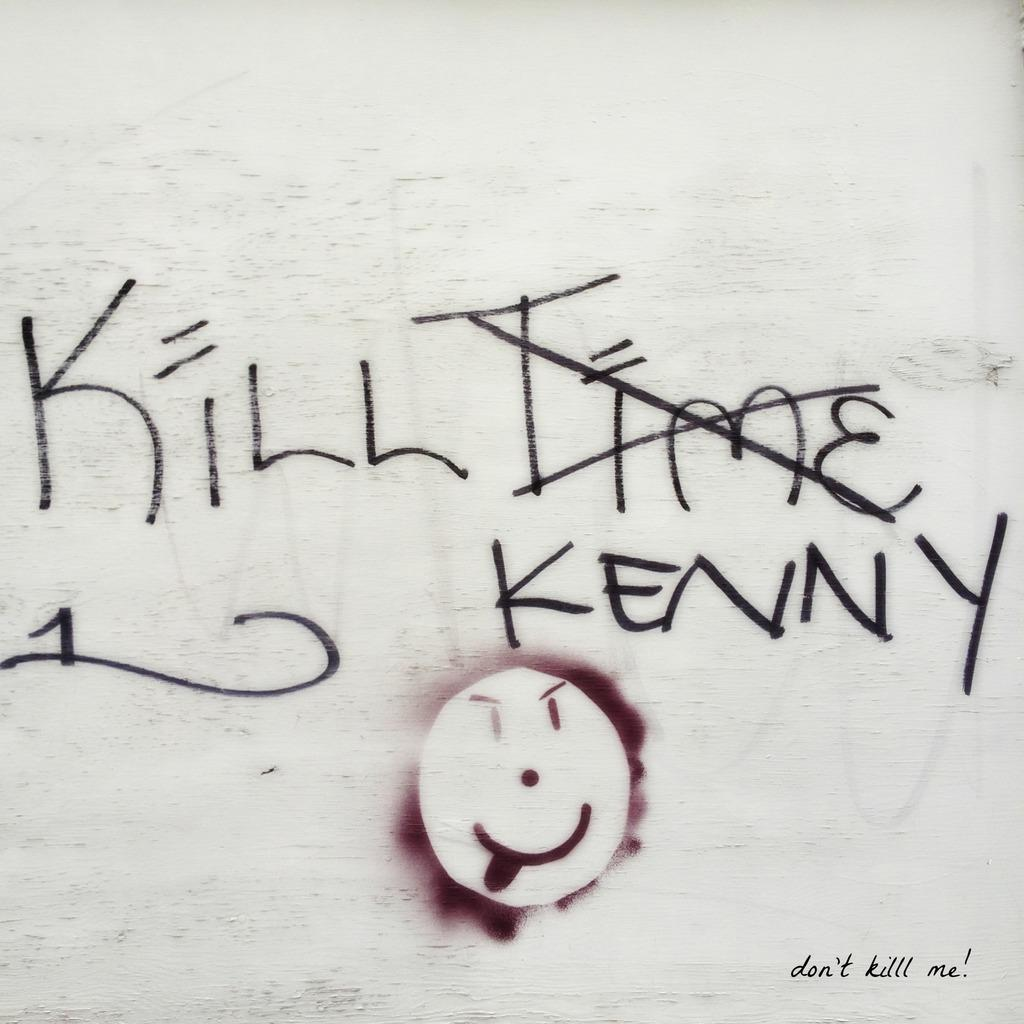What is the color of the surface in the image? The surface in the image is white. What can be seen written on the surface? There are words written on the surface in black color. What additional feature is present on the surface? There is a design or object painted with maroon color on the surface. What type of vegetable is being used as a payment method in the image? There is no vegetable or payment method present in the image. 